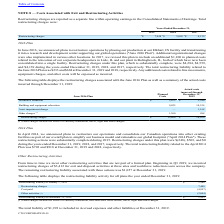According to Cts Corporation's financial document, What were the planned costs for Other Charges? According to the financial document, 1,300 (in thousands). The relevant text states: "Other charges (1) 1,300 988..." Also, What were the actual restructuring costs? According to the financial document, 16,030 (in thousands). The relevant text states: "Restructuring charges $ 13,400 $ 16,030..." Also, What was the actual amount of Building and Equipment Relocation costs? According to the financial document, 10,534 (in thousands). The relevant text states: "Building and equipment relocation 9,025 10,534..." Also, can you calculate: What was the difference between the planned costs and actual costs incurred for Building and Equipment Relocation? Based on the calculation: 10,534-9,025, the result is 1509 (in thousands). This is based on the information: "Building and equipment relocation 9,025 10,534 Building and equipment relocation 9,025 10,534..." The key data points involved are: 10,534, 9,025. Also, can you calculate: What was the difference between the planned costs and actual costs incurred for Workforce Reduction? Based on the calculation: 3,340-3,075, the result is 265 (in thousands). This is based on the information: "Workforce reduction $ 3,075 $ 3,340 Workforce reduction $ 3,075 $ 3,340..." The key data points involved are: 3,075, 3,340. Also, can you calculate: What was the difference between the planned costs and actual costs incurred for total Restructuring Charges? Based on the calculation: 16,030-13,400, the result is 2630 (in thousands). This is based on the information: "Restructuring charges $ 13,400 $ 16,030 Restructuring charges $ 13,400 $ 16,030..." The key data points involved are: 13,400, 16,030. 